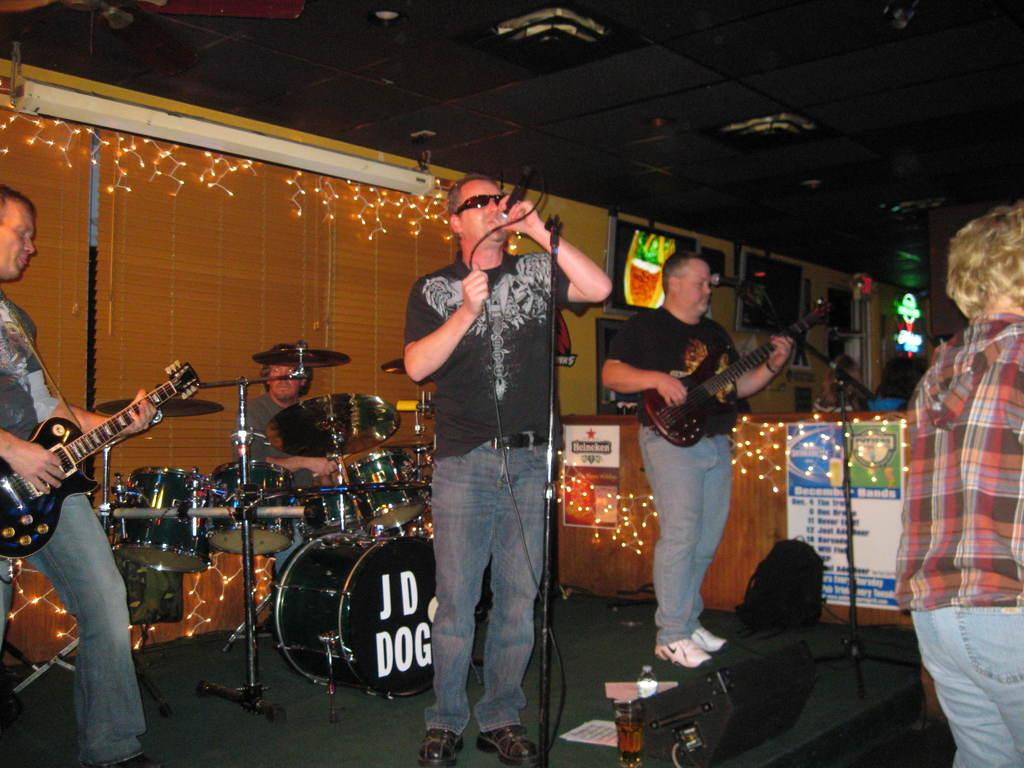How many people are in the image? There is a group of persons in the image. What are the persons in the image doing? The persons are playing musical instruments. What type of fold can be seen in the image? There is no fold present in the image; it features a group of persons playing musical instruments. What type of slave is depicted in the image? There is no slave depicted in the image; it features a group of persons playing musical instruments. 